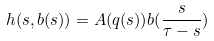<formula> <loc_0><loc_0><loc_500><loc_500>h ( s , { b } ( s ) ) = { A } ( { q } ( s ) ) { b } ( \frac { s } { \tau - s } )</formula> 